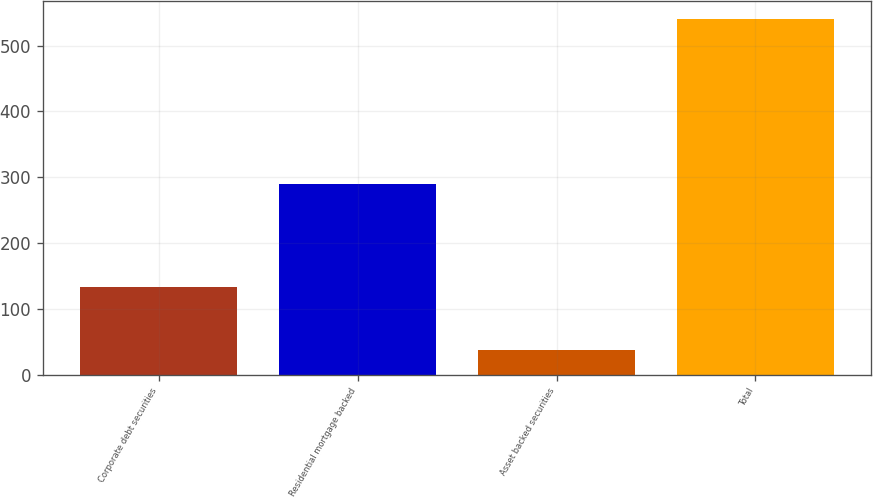<chart> <loc_0><loc_0><loc_500><loc_500><bar_chart><fcel>Corporate debt securities<fcel>Residential mortgage backed<fcel>Asset backed securities<fcel>Total<nl><fcel>134<fcel>290<fcel>38<fcel>540<nl></chart> 